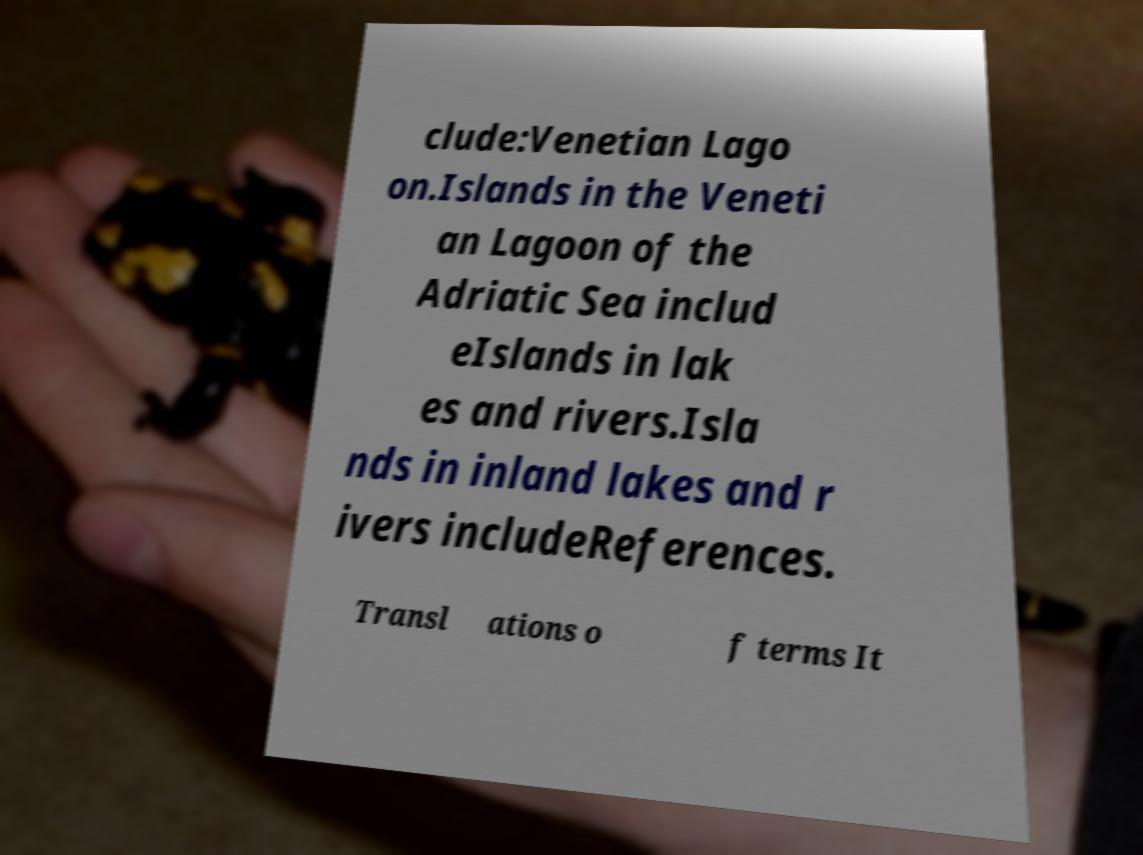I need the written content from this picture converted into text. Can you do that? clude:Venetian Lago on.Islands in the Veneti an Lagoon of the Adriatic Sea includ eIslands in lak es and rivers.Isla nds in inland lakes and r ivers includeReferences. Transl ations o f terms It 